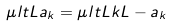Convert formula to latex. <formula><loc_0><loc_0><loc_500><loc_500>\mu l t { L } { a } _ { k } = \mu l t { L } { k L - a } _ { k }</formula> 